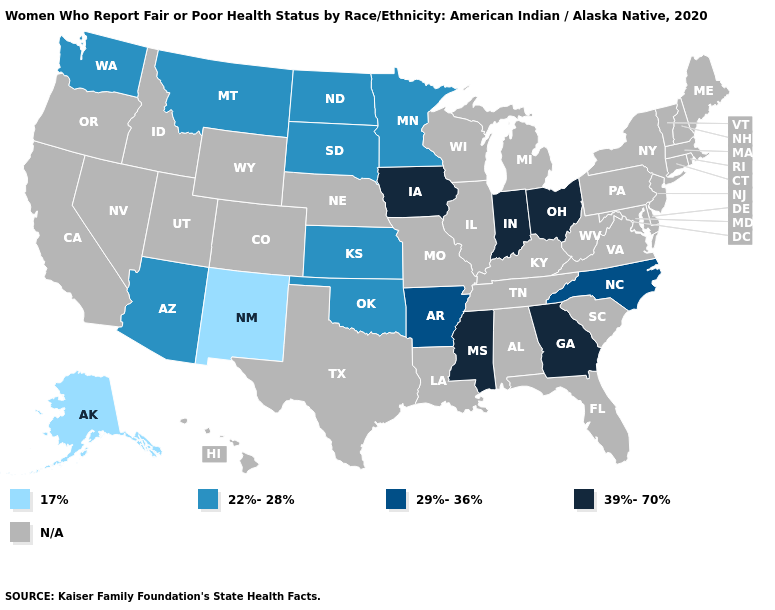Name the states that have a value in the range 17%?
Short answer required. Alaska, New Mexico. Does the first symbol in the legend represent the smallest category?
Write a very short answer. Yes. Name the states that have a value in the range 39%-70%?
Answer briefly. Georgia, Indiana, Iowa, Mississippi, Ohio. What is the lowest value in the USA?
Write a very short answer. 17%. How many symbols are there in the legend?
Answer briefly. 5. What is the lowest value in the South?
Answer briefly. 22%-28%. Does North Carolina have the highest value in the USA?
Keep it brief. No. What is the highest value in the USA?
Concise answer only. 39%-70%. Name the states that have a value in the range 39%-70%?
Write a very short answer. Georgia, Indiana, Iowa, Mississippi, Ohio. 